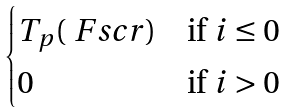Convert formula to latex. <formula><loc_0><loc_0><loc_500><loc_500>\begin{cases} T _ { p } ( \ F s c r ) & \text {if $i\leq 0$} \\ 0 & \text {if $i>0$} \end{cases}</formula> 